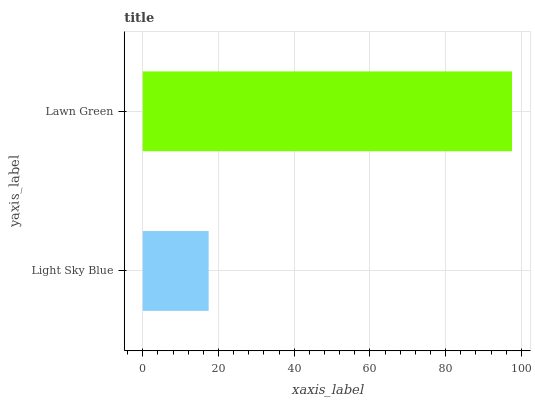Is Light Sky Blue the minimum?
Answer yes or no. Yes. Is Lawn Green the maximum?
Answer yes or no. Yes. Is Lawn Green the minimum?
Answer yes or no. No. Is Lawn Green greater than Light Sky Blue?
Answer yes or no. Yes. Is Light Sky Blue less than Lawn Green?
Answer yes or no. Yes. Is Light Sky Blue greater than Lawn Green?
Answer yes or no. No. Is Lawn Green less than Light Sky Blue?
Answer yes or no. No. Is Lawn Green the high median?
Answer yes or no. Yes. Is Light Sky Blue the low median?
Answer yes or no. Yes. Is Light Sky Blue the high median?
Answer yes or no. No. Is Lawn Green the low median?
Answer yes or no. No. 